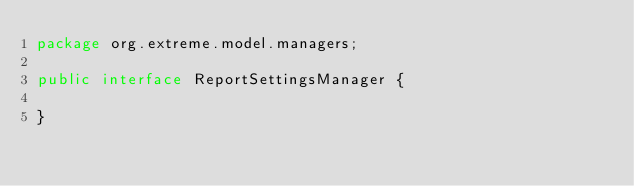<code> <loc_0><loc_0><loc_500><loc_500><_Java_>package org.extreme.model.managers;

public interface ReportSettingsManager {

}
</code> 